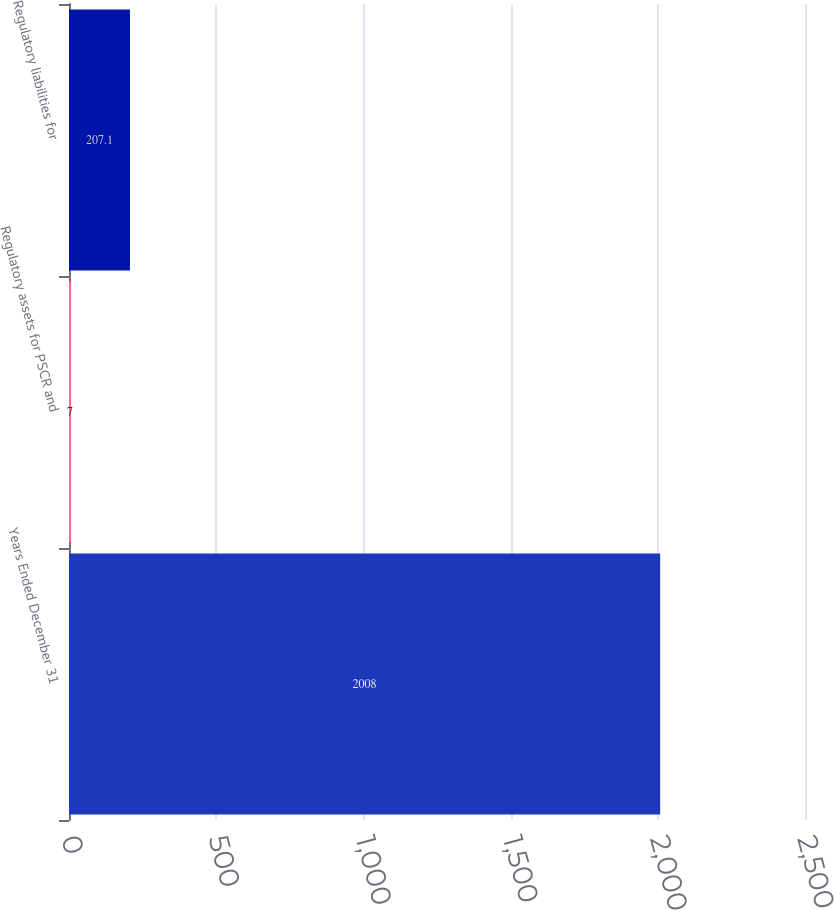<chart> <loc_0><loc_0><loc_500><loc_500><bar_chart><fcel>Years Ended December 31<fcel>Regulatory assets for PSCR and<fcel>Regulatory liabilities for<nl><fcel>2008<fcel>7<fcel>207.1<nl></chart> 